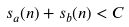<formula> <loc_0><loc_0><loc_500><loc_500>s _ { a } ( n ) + s _ { b } ( n ) < C</formula> 